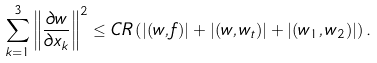Convert formula to latex. <formula><loc_0><loc_0><loc_500><loc_500>\sum _ { k = 1 } ^ { 3 } \left \| \frac { \partial w } { \partial x _ { k } } \right \| ^ { 2 } \leq C R \left ( | ( w , f ) | + | ( w , w _ { t } ) | + | ( w _ { 1 } , w _ { 2 } ) | \right ) .</formula> 